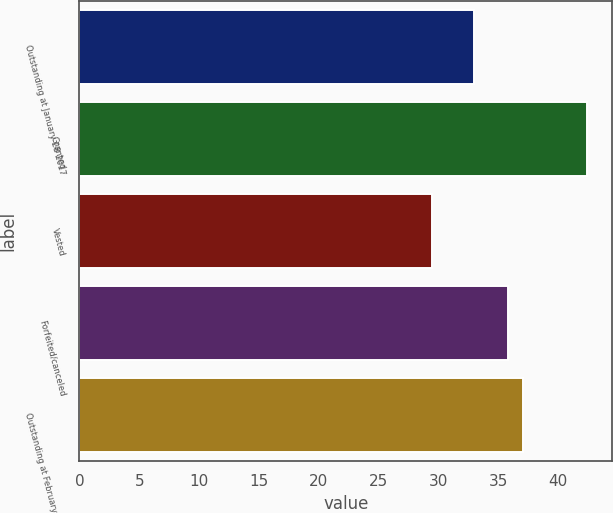Convert chart to OTSL. <chart><loc_0><loc_0><loc_500><loc_500><bar_chart><fcel>Outstanding at January 28 2017<fcel>Granted<fcel>Vested<fcel>Forfeited/canceled<fcel>Outstanding at February 3 2018<nl><fcel>32.99<fcel>42.4<fcel>29.46<fcel>35.81<fcel>37.1<nl></chart> 